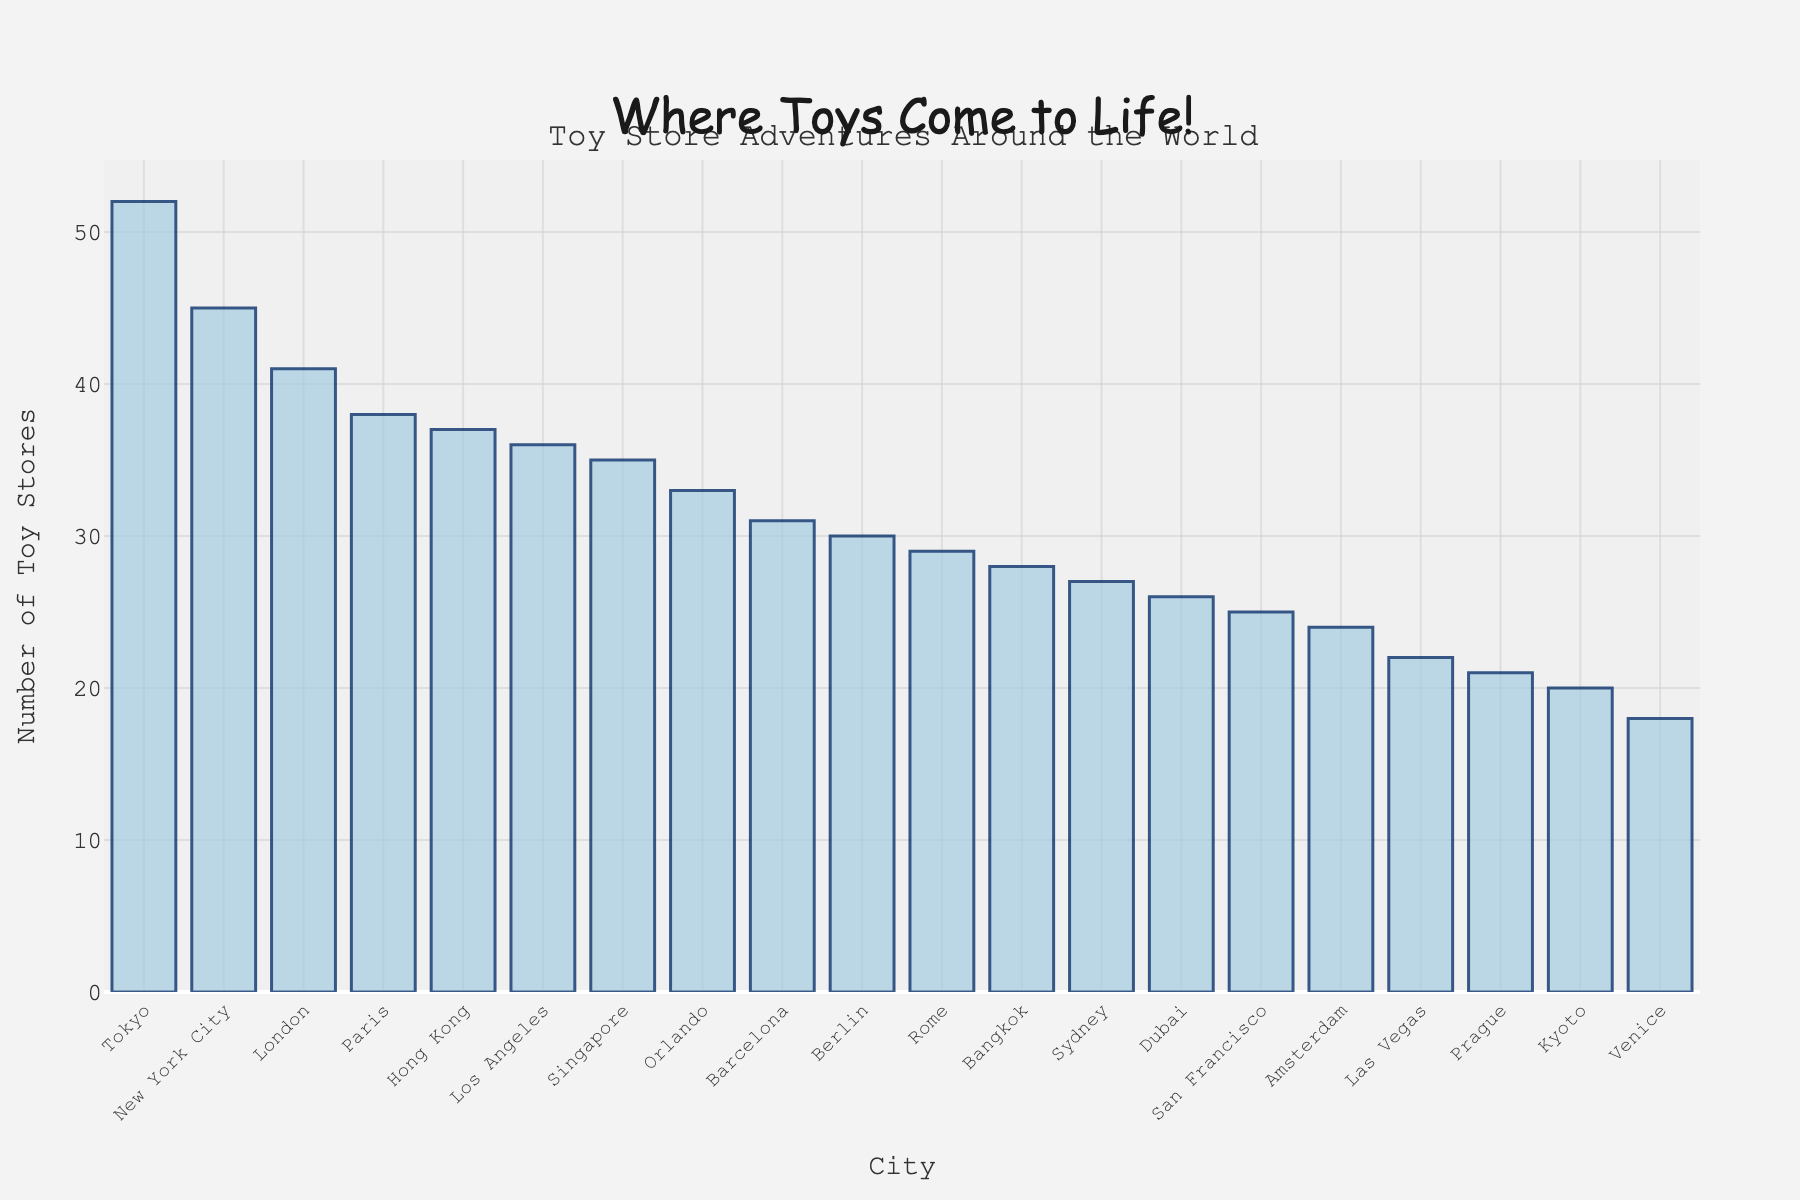Which city has the highest number of toy stores? By observing the height of the bars, Tokyo's bar is the tallest, indicating it has the highest number of toy stores.
Answer: Tokyo Which city has the fewest toy stores? The shortest bar belongs to Venice, indicating it has the fewest toy stores.
Answer: Venice How many more toy stores does New York City have compared to Venice? New York City's bar represents 45 toy stores, and Venice's represents 18. The difference is 45 - 18 = 27.
Answer: 27 What is the total number of toy stores in Paris, Rome, and Barcelona? Add the numbers for each city: 38 (Paris) + 29 (Rome) + 31 (Barcelona) = 98.
Answer: 98 Which cities have more than 35 toy stores? By observing the heights of the bars, the cities with bars taller than the 35 marker line are Paris, New York City, Tokyo, London, and Los Angeles.
Answer: Paris, New York City, Tokyo, London, Los Angeles Which city has slightly fewer toy stores than London? The bar height for Los Angeles is just below London's bar height, indicating it has slightly fewer toy stores.
Answer: Los Angeles How many cities have between 20 and 30 toy stores? The cities in this range are Rome, Orlando, Hong Kong, Dubai, Barcelona, Sydney, Berlin, Bangkok, San Francisco, Kyoto, Amsterdam, Las Vegas, Prague, and Venice. Count these cities.
Answer: 12 What is the average number of toy stores in the listed cities? Sum all the number of toy stores and divide by the number of cities: (38 + 45 + 52 + 41 + 29 + 33 + 37 + 26 + 31 + 35 + 24 + 28 + 22 + 27 + 30 + 18 + 36 + 21 + 25 + 20) / 20 = 695 / 20.
Answer: 34.75 Compare the number of toy stores in Berlin and Singapore. Which one has more? The bar for Singapore is taller than the one for Berlin, indicating Singapore has more toy stores.
Answer: Singapore 